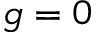<formula> <loc_0><loc_0><loc_500><loc_500>g = 0</formula> 